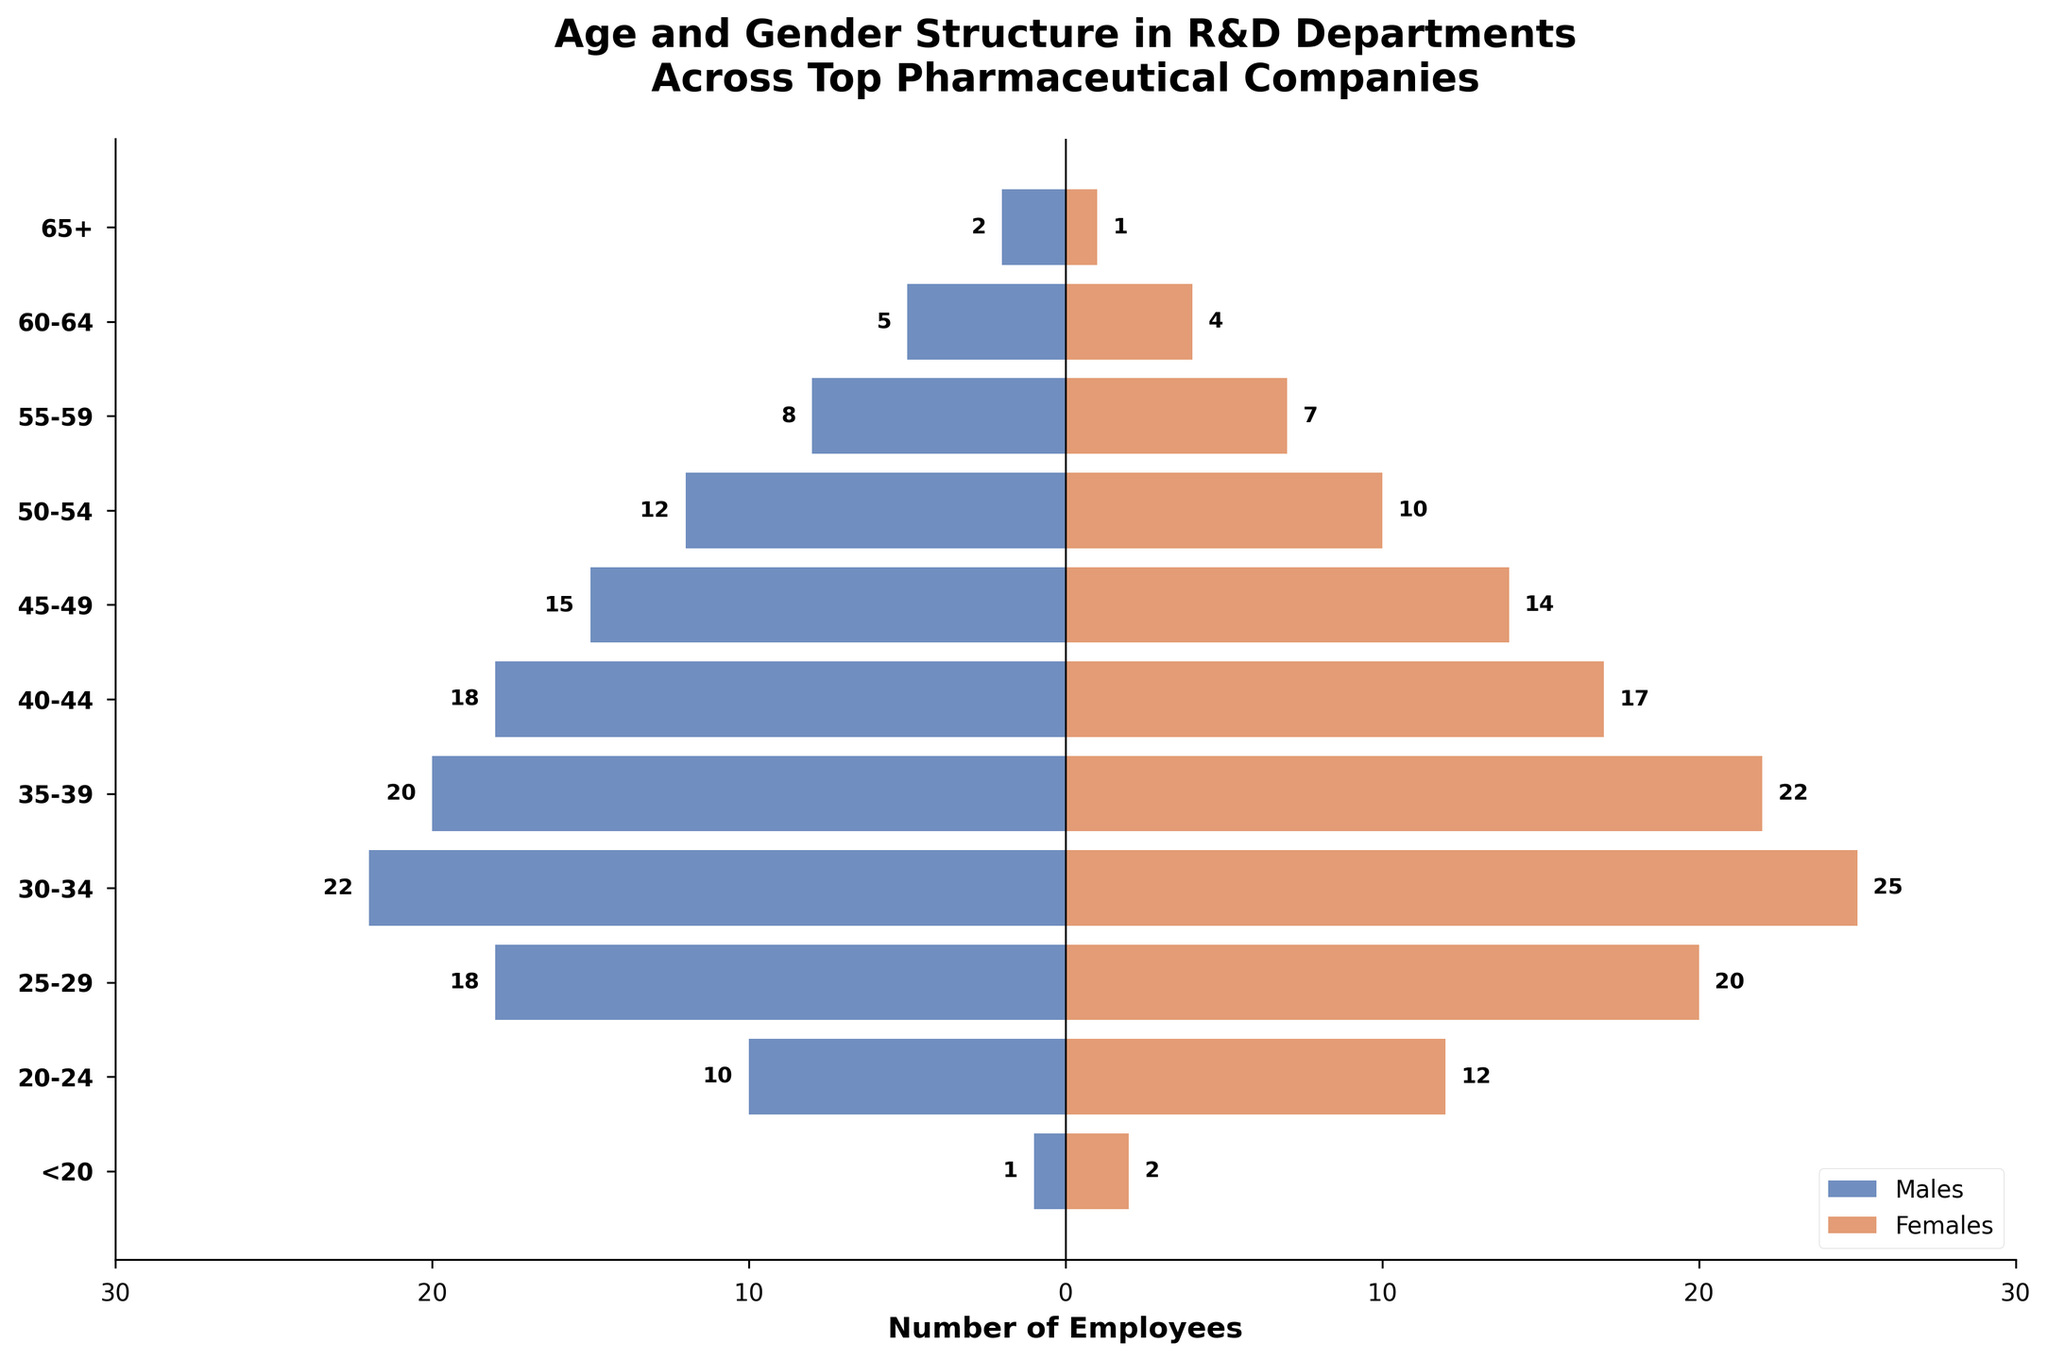What is the title of the figure? The title is usually displayed at the top of the figure. In this figure, it is centered and bold, directly describing the content.
Answer: Age and Gender Structure in R&D Departments Across Top Pharmaceutical Companies How many age groups are displayed in the figure? Count the number of unique age group labels on the y-axis of the figure.
Answer: 11 Which age group has the maximum number of female employees? Look at the bar lengths for females in each age group and identify the longest bar.
Answer: 30-34 How many males are in the 40-44 age group? Identify the bar corresponding to the 40-44 age group and read the value labeled beside it.
Answer: 18 Compare the number of males and females in the 25-29 age group. Who are more, and by how much? Find the bar lengths for both males and females in the 25-29 age group, then calculate the difference.
Answer: Females; 2 more What is the total number of employees aged under 20? Add the number of males and females in the <20 age group.
Answer: 3 What is the median number of female employees across all age groups? List the number of females in each age group, sort the list, and find the middle value or the average of the two middle values if the list length is even.
Answer: 10 Which age group has the closest number of males and females? Calculate the absolute difference between the number of males and females in each age group, then identify the smallest difference.
Answer: <20; difference is 1 Is there any age group where the number of employees (male + female) is greater than 40? If yes, name the group. Calculate the total employees for each age group by adding the number of males and females, then check if any group's total exceeds 40.
Answer: No 